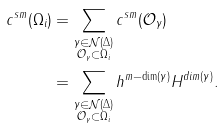<formula> <loc_0><loc_0><loc_500><loc_500>c ^ { s m } ( \Omega _ { i } ) & = \sum _ { \substack { \gamma \in \mathcal { N } ( \Delta ) \\ \mathcal { O } _ { \gamma } \subset \Omega _ { i } } } c ^ { s m } ( \mathcal { O } _ { \gamma } ) \\ & = \sum _ { \substack { \gamma \in \mathcal { N } ( \Delta ) \\ \mathcal { O } _ { \gamma } \subset \Omega _ { i } } } h ^ { m - \dim ( \gamma ) } H ^ { d i m ( \gamma ) } .</formula> 